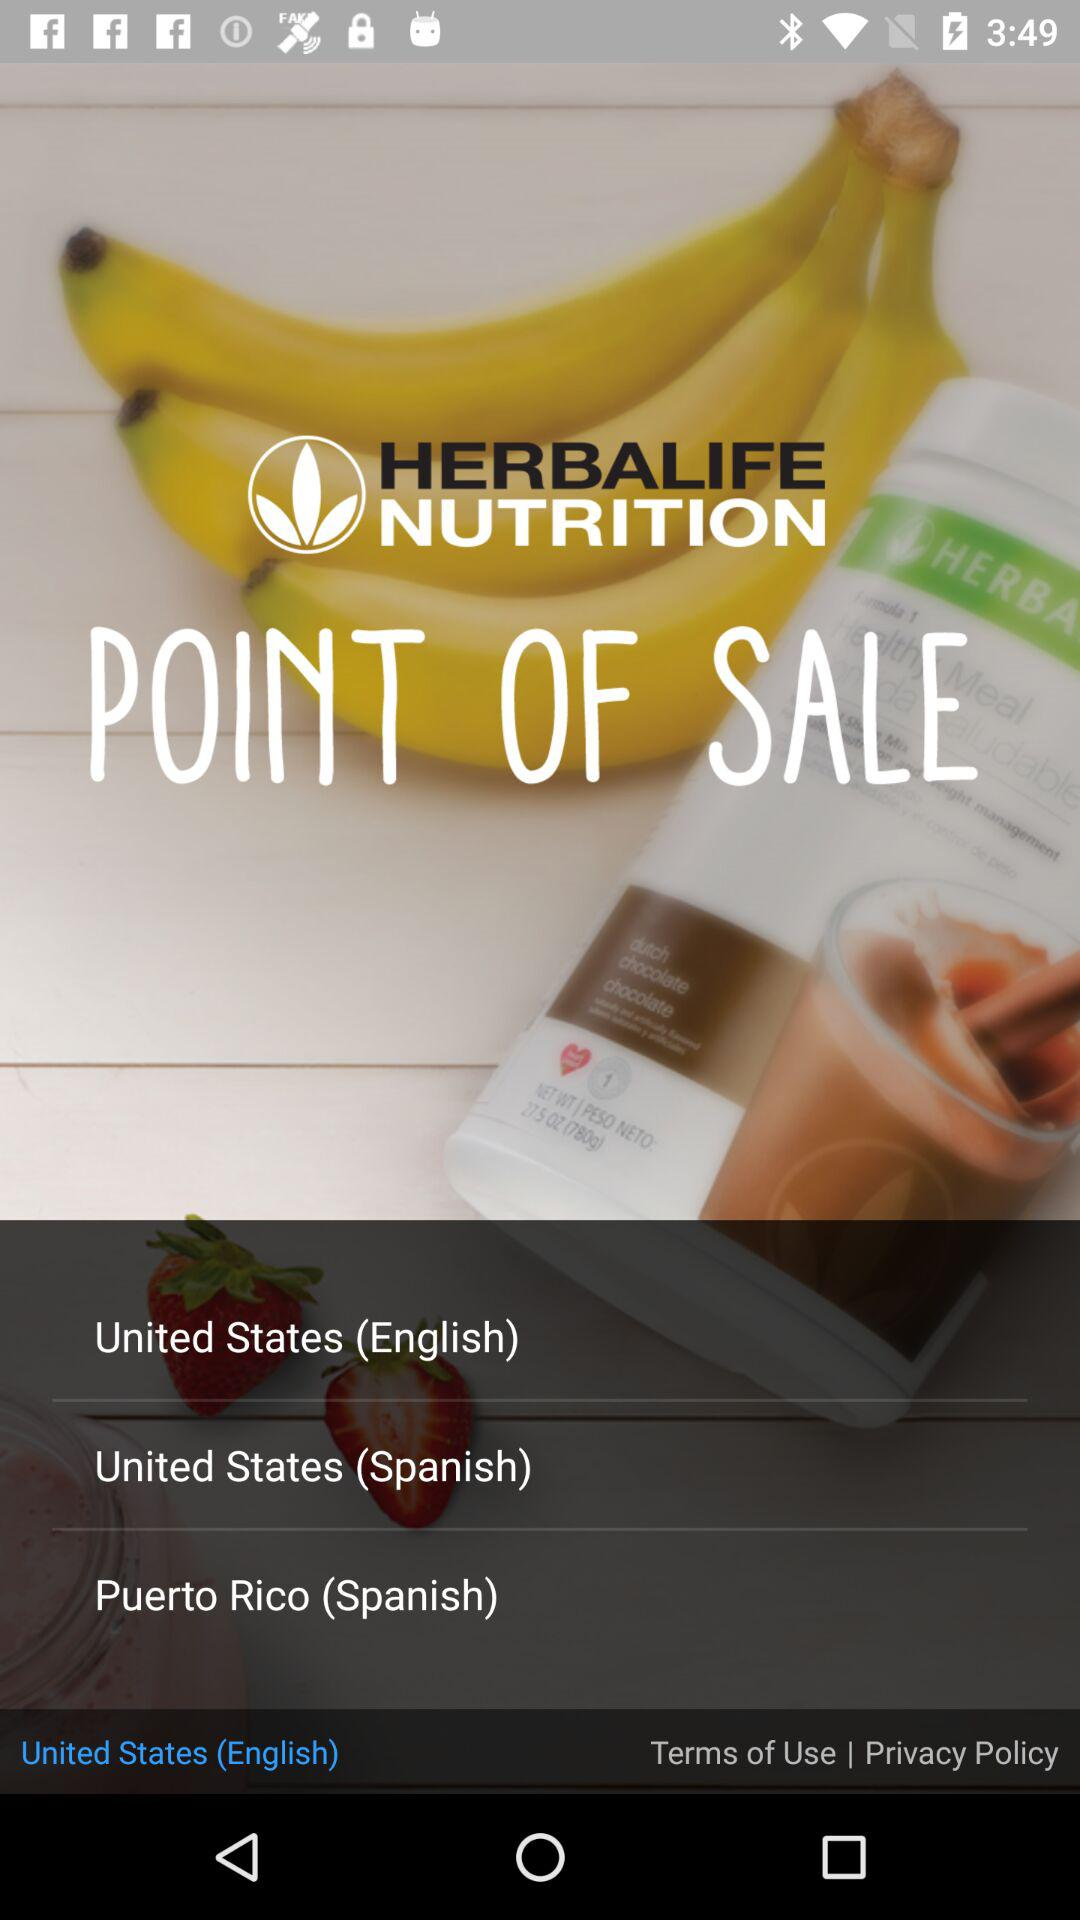What are the different options? The different options are "United States (English)", "United States (Spanish)" and "Puerto Rico (Spanish)". 